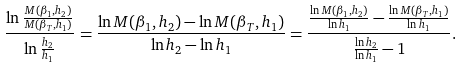Convert formula to latex. <formula><loc_0><loc_0><loc_500><loc_500>\frac { \ln \frac { M ( \beta _ { 1 } , h _ { 2 } ) } { M ( \beta _ { T } , h _ { 1 } ) } } { \ln \frac { h _ { 2 } } { h _ { 1 } } } = \frac { \ln M ( \beta _ { 1 } , h _ { 2 } ) - \ln M ( \beta _ { T } , h _ { 1 } ) } { \ln h _ { 2 } - \ln h _ { 1 } } = \frac { \frac { \ln M ( \beta _ { 1 } , h _ { 2 } ) } { \ln h _ { 1 } } - \frac { \ln M ( \beta _ { T } , h _ { 1 } ) } { \ln h _ { 1 } } } { \frac { \ln h _ { 2 } } { \ln h _ { 1 } } - 1 } .</formula> 